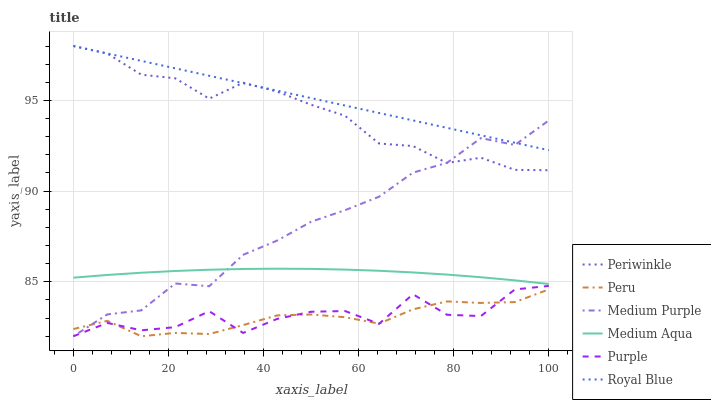Does Peru have the minimum area under the curve?
Answer yes or no. Yes. Does Royal Blue have the maximum area under the curve?
Answer yes or no. Yes. Does Medium Purple have the minimum area under the curve?
Answer yes or no. No. Does Medium Purple have the maximum area under the curve?
Answer yes or no. No. Is Royal Blue the smoothest?
Answer yes or no. Yes. Is Purple the roughest?
Answer yes or no. Yes. Is Medium Purple the smoothest?
Answer yes or no. No. Is Medium Purple the roughest?
Answer yes or no. No. Does Purple have the lowest value?
Answer yes or no. Yes. Does Royal Blue have the lowest value?
Answer yes or no. No. Does Periwinkle have the highest value?
Answer yes or no. Yes. Does Medium Purple have the highest value?
Answer yes or no. No. Is Medium Aqua less than Periwinkle?
Answer yes or no. Yes. Is Periwinkle greater than Purple?
Answer yes or no. Yes. Does Medium Purple intersect Peru?
Answer yes or no. Yes. Is Medium Purple less than Peru?
Answer yes or no. No. Is Medium Purple greater than Peru?
Answer yes or no. No. Does Medium Aqua intersect Periwinkle?
Answer yes or no. No. 